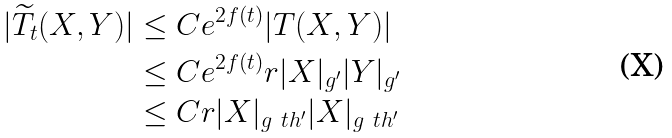<formula> <loc_0><loc_0><loc_500><loc_500>| \widetilde { T } _ { t } ( X , Y ) | & \leq C e ^ { 2 f ( t ) } | T ( X , Y ) | \\ & \leq C e ^ { 2 f ( t ) } r | X | _ { g ^ { \prime } } | Y | _ { g ^ { \prime } } \\ & \leq C r | X | _ { g _ { \ } t h ^ { \prime } } | X | _ { g _ { \ } t h ^ { \prime } }</formula> 